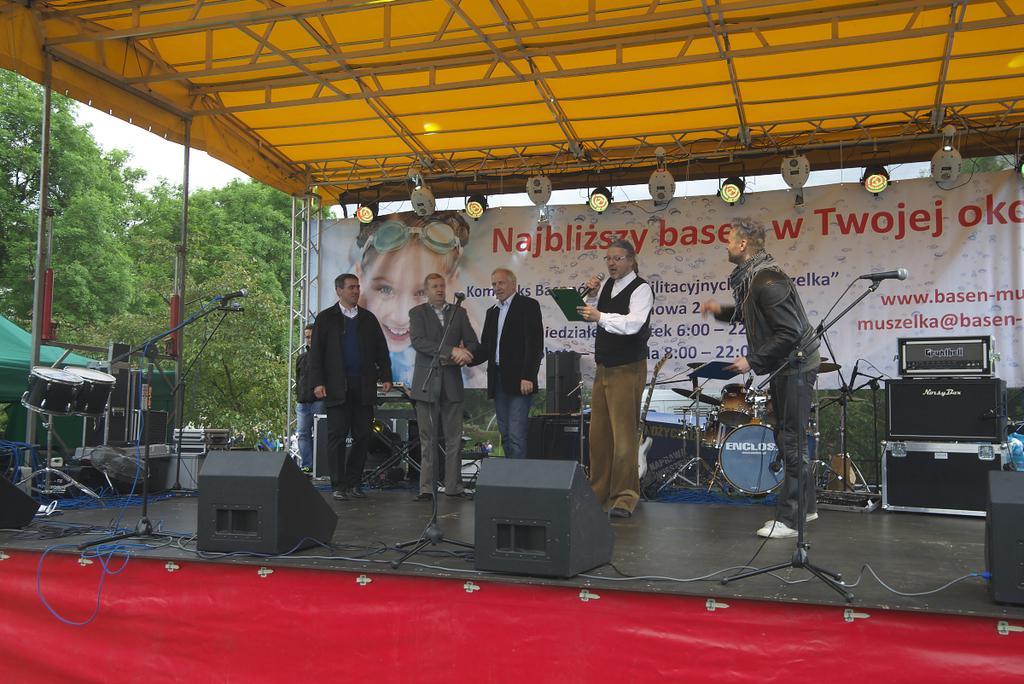Please provide a concise description of this image. Here I can see few men standing on the stage. Two men are shaking their hands and one man is holding a sheet in hand and speaking something on mike. In the background, I can see some musical instruments. At the bottom of the image I can see a red color mat. In the background there is a white color board on which I can see some text and an image of a person. On the top of the image there is a yellow color tint. In the background, I can see the trees. 